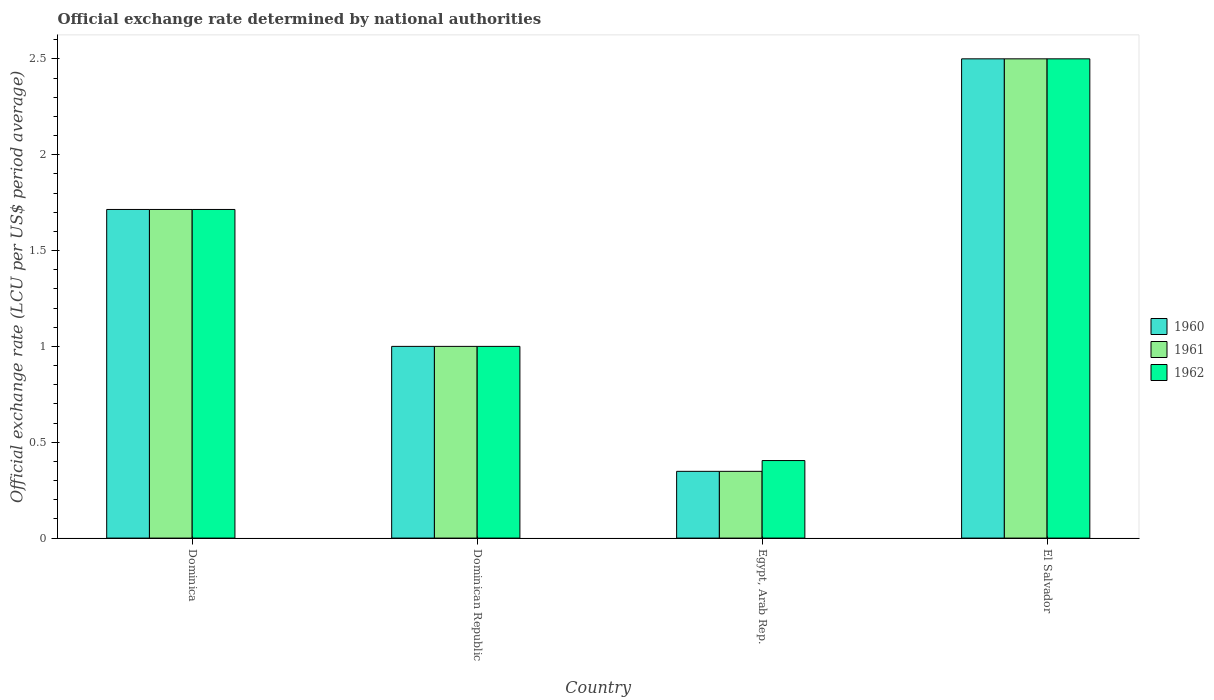Are the number of bars on each tick of the X-axis equal?
Provide a short and direct response. Yes. How many bars are there on the 1st tick from the left?
Offer a very short reply. 3. What is the label of the 2nd group of bars from the left?
Offer a very short reply. Dominican Republic. What is the official exchange rate in 1962 in El Salvador?
Ensure brevity in your answer.  2.5. Across all countries, what is the maximum official exchange rate in 1960?
Offer a terse response. 2.5. Across all countries, what is the minimum official exchange rate in 1960?
Provide a succinct answer. 0.35. In which country was the official exchange rate in 1962 maximum?
Your response must be concise. El Salvador. In which country was the official exchange rate in 1962 minimum?
Offer a very short reply. Egypt, Arab Rep. What is the total official exchange rate in 1961 in the graph?
Offer a terse response. 5.56. What is the difference between the official exchange rate in 1960 in Egypt, Arab Rep. and that in El Salvador?
Give a very brief answer. -2.15. What is the difference between the official exchange rate in 1962 in Dominican Republic and the official exchange rate in 1961 in Egypt, Arab Rep.?
Your response must be concise. 0.65. What is the average official exchange rate in 1962 per country?
Make the answer very short. 1.4. In how many countries, is the official exchange rate in 1962 greater than 0.1 LCU?
Keep it short and to the point. 4. What is the ratio of the official exchange rate in 1962 in Egypt, Arab Rep. to that in El Salvador?
Provide a succinct answer. 0.16. Is the official exchange rate in 1961 in Dominica less than that in Egypt, Arab Rep.?
Your answer should be compact. No. Is the difference between the official exchange rate in 1960 in Dominica and El Salvador greater than the difference between the official exchange rate in 1962 in Dominica and El Salvador?
Your response must be concise. No. What is the difference between the highest and the second highest official exchange rate in 1961?
Your response must be concise. -0.79. What is the difference between the highest and the lowest official exchange rate in 1962?
Your response must be concise. 2.1. What does the 3rd bar from the left in Dominica represents?
Your answer should be compact. 1962. Is it the case that in every country, the sum of the official exchange rate in 1961 and official exchange rate in 1960 is greater than the official exchange rate in 1962?
Offer a very short reply. Yes. Are the values on the major ticks of Y-axis written in scientific E-notation?
Your answer should be very brief. No. Does the graph contain grids?
Give a very brief answer. No. Where does the legend appear in the graph?
Your answer should be compact. Center right. How are the legend labels stacked?
Offer a terse response. Vertical. What is the title of the graph?
Provide a short and direct response. Official exchange rate determined by national authorities. Does "1993" appear as one of the legend labels in the graph?
Offer a terse response. No. What is the label or title of the X-axis?
Make the answer very short. Country. What is the label or title of the Y-axis?
Ensure brevity in your answer.  Official exchange rate (LCU per US$ period average). What is the Official exchange rate (LCU per US$ period average) in 1960 in Dominica?
Your response must be concise. 1.71. What is the Official exchange rate (LCU per US$ period average) of 1961 in Dominica?
Your answer should be very brief. 1.71. What is the Official exchange rate (LCU per US$ period average) in 1962 in Dominica?
Make the answer very short. 1.71. What is the Official exchange rate (LCU per US$ period average) in 1960 in Dominican Republic?
Your answer should be very brief. 1. What is the Official exchange rate (LCU per US$ period average) in 1960 in Egypt, Arab Rep.?
Provide a short and direct response. 0.35. What is the Official exchange rate (LCU per US$ period average) of 1961 in Egypt, Arab Rep.?
Offer a terse response. 0.35. What is the Official exchange rate (LCU per US$ period average) of 1962 in Egypt, Arab Rep.?
Your answer should be very brief. 0.4. What is the Official exchange rate (LCU per US$ period average) in 1960 in El Salvador?
Keep it short and to the point. 2.5. What is the Official exchange rate (LCU per US$ period average) of 1961 in El Salvador?
Provide a short and direct response. 2.5. What is the Official exchange rate (LCU per US$ period average) of 1962 in El Salvador?
Give a very brief answer. 2.5. Across all countries, what is the maximum Official exchange rate (LCU per US$ period average) in 1960?
Provide a succinct answer. 2.5. Across all countries, what is the maximum Official exchange rate (LCU per US$ period average) in 1961?
Your response must be concise. 2.5. Across all countries, what is the maximum Official exchange rate (LCU per US$ period average) of 1962?
Your answer should be very brief. 2.5. Across all countries, what is the minimum Official exchange rate (LCU per US$ period average) of 1960?
Offer a terse response. 0.35. Across all countries, what is the minimum Official exchange rate (LCU per US$ period average) of 1961?
Your answer should be compact. 0.35. Across all countries, what is the minimum Official exchange rate (LCU per US$ period average) in 1962?
Offer a terse response. 0.4. What is the total Official exchange rate (LCU per US$ period average) of 1960 in the graph?
Your answer should be very brief. 5.56. What is the total Official exchange rate (LCU per US$ period average) in 1961 in the graph?
Your response must be concise. 5.56. What is the total Official exchange rate (LCU per US$ period average) of 1962 in the graph?
Ensure brevity in your answer.  5.62. What is the difference between the Official exchange rate (LCU per US$ period average) of 1960 in Dominica and that in Dominican Republic?
Your answer should be compact. 0.71. What is the difference between the Official exchange rate (LCU per US$ period average) in 1961 in Dominica and that in Dominican Republic?
Offer a very short reply. 0.71. What is the difference between the Official exchange rate (LCU per US$ period average) in 1960 in Dominica and that in Egypt, Arab Rep.?
Give a very brief answer. 1.37. What is the difference between the Official exchange rate (LCU per US$ period average) of 1961 in Dominica and that in Egypt, Arab Rep.?
Provide a short and direct response. 1.37. What is the difference between the Official exchange rate (LCU per US$ period average) of 1962 in Dominica and that in Egypt, Arab Rep.?
Provide a succinct answer. 1.31. What is the difference between the Official exchange rate (LCU per US$ period average) in 1960 in Dominica and that in El Salvador?
Offer a very short reply. -0.79. What is the difference between the Official exchange rate (LCU per US$ period average) of 1961 in Dominica and that in El Salvador?
Your response must be concise. -0.79. What is the difference between the Official exchange rate (LCU per US$ period average) of 1962 in Dominica and that in El Salvador?
Keep it short and to the point. -0.79. What is the difference between the Official exchange rate (LCU per US$ period average) in 1960 in Dominican Republic and that in Egypt, Arab Rep.?
Keep it short and to the point. 0.65. What is the difference between the Official exchange rate (LCU per US$ period average) in 1961 in Dominican Republic and that in Egypt, Arab Rep.?
Your answer should be compact. 0.65. What is the difference between the Official exchange rate (LCU per US$ period average) of 1962 in Dominican Republic and that in Egypt, Arab Rep.?
Provide a succinct answer. 0.6. What is the difference between the Official exchange rate (LCU per US$ period average) of 1960 in Dominican Republic and that in El Salvador?
Make the answer very short. -1.5. What is the difference between the Official exchange rate (LCU per US$ period average) of 1962 in Dominican Republic and that in El Salvador?
Your answer should be compact. -1.5. What is the difference between the Official exchange rate (LCU per US$ period average) of 1960 in Egypt, Arab Rep. and that in El Salvador?
Offer a very short reply. -2.15. What is the difference between the Official exchange rate (LCU per US$ period average) in 1961 in Egypt, Arab Rep. and that in El Salvador?
Offer a terse response. -2.15. What is the difference between the Official exchange rate (LCU per US$ period average) of 1962 in Egypt, Arab Rep. and that in El Salvador?
Ensure brevity in your answer.  -2.1. What is the difference between the Official exchange rate (LCU per US$ period average) of 1960 in Dominica and the Official exchange rate (LCU per US$ period average) of 1961 in Dominican Republic?
Keep it short and to the point. 0.71. What is the difference between the Official exchange rate (LCU per US$ period average) in 1961 in Dominica and the Official exchange rate (LCU per US$ period average) in 1962 in Dominican Republic?
Provide a succinct answer. 0.71. What is the difference between the Official exchange rate (LCU per US$ period average) of 1960 in Dominica and the Official exchange rate (LCU per US$ period average) of 1961 in Egypt, Arab Rep.?
Offer a terse response. 1.37. What is the difference between the Official exchange rate (LCU per US$ period average) of 1960 in Dominica and the Official exchange rate (LCU per US$ period average) of 1962 in Egypt, Arab Rep.?
Make the answer very short. 1.31. What is the difference between the Official exchange rate (LCU per US$ period average) of 1961 in Dominica and the Official exchange rate (LCU per US$ period average) of 1962 in Egypt, Arab Rep.?
Offer a terse response. 1.31. What is the difference between the Official exchange rate (LCU per US$ period average) in 1960 in Dominica and the Official exchange rate (LCU per US$ period average) in 1961 in El Salvador?
Your answer should be very brief. -0.79. What is the difference between the Official exchange rate (LCU per US$ period average) of 1960 in Dominica and the Official exchange rate (LCU per US$ period average) of 1962 in El Salvador?
Give a very brief answer. -0.79. What is the difference between the Official exchange rate (LCU per US$ period average) in 1961 in Dominica and the Official exchange rate (LCU per US$ period average) in 1962 in El Salvador?
Offer a very short reply. -0.79. What is the difference between the Official exchange rate (LCU per US$ period average) in 1960 in Dominican Republic and the Official exchange rate (LCU per US$ period average) in 1961 in Egypt, Arab Rep.?
Your answer should be very brief. 0.65. What is the difference between the Official exchange rate (LCU per US$ period average) of 1960 in Dominican Republic and the Official exchange rate (LCU per US$ period average) of 1962 in Egypt, Arab Rep.?
Make the answer very short. 0.6. What is the difference between the Official exchange rate (LCU per US$ period average) of 1961 in Dominican Republic and the Official exchange rate (LCU per US$ period average) of 1962 in Egypt, Arab Rep.?
Make the answer very short. 0.6. What is the difference between the Official exchange rate (LCU per US$ period average) in 1960 in Egypt, Arab Rep. and the Official exchange rate (LCU per US$ period average) in 1961 in El Salvador?
Provide a short and direct response. -2.15. What is the difference between the Official exchange rate (LCU per US$ period average) in 1960 in Egypt, Arab Rep. and the Official exchange rate (LCU per US$ period average) in 1962 in El Salvador?
Offer a terse response. -2.15. What is the difference between the Official exchange rate (LCU per US$ period average) in 1961 in Egypt, Arab Rep. and the Official exchange rate (LCU per US$ period average) in 1962 in El Salvador?
Ensure brevity in your answer.  -2.15. What is the average Official exchange rate (LCU per US$ period average) of 1960 per country?
Keep it short and to the point. 1.39. What is the average Official exchange rate (LCU per US$ period average) in 1961 per country?
Make the answer very short. 1.39. What is the average Official exchange rate (LCU per US$ period average) of 1962 per country?
Give a very brief answer. 1.4. What is the difference between the Official exchange rate (LCU per US$ period average) of 1960 and Official exchange rate (LCU per US$ period average) of 1961 in Dominica?
Ensure brevity in your answer.  0. What is the difference between the Official exchange rate (LCU per US$ period average) of 1960 and Official exchange rate (LCU per US$ period average) of 1962 in Dominican Republic?
Your response must be concise. 0. What is the difference between the Official exchange rate (LCU per US$ period average) in 1961 and Official exchange rate (LCU per US$ period average) in 1962 in Dominican Republic?
Give a very brief answer. 0. What is the difference between the Official exchange rate (LCU per US$ period average) in 1960 and Official exchange rate (LCU per US$ period average) in 1961 in Egypt, Arab Rep.?
Keep it short and to the point. 0. What is the difference between the Official exchange rate (LCU per US$ period average) in 1960 and Official exchange rate (LCU per US$ period average) in 1962 in Egypt, Arab Rep.?
Provide a succinct answer. -0.06. What is the difference between the Official exchange rate (LCU per US$ period average) in 1961 and Official exchange rate (LCU per US$ period average) in 1962 in Egypt, Arab Rep.?
Your answer should be compact. -0.06. What is the difference between the Official exchange rate (LCU per US$ period average) in 1961 and Official exchange rate (LCU per US$ period average) in 1962 in El Salvador?
Your response must be concise. 0. What is the ratio of the Official exchange rate (LCU per US$ period average) of 1960 in Dominica to that in Dominican Republic?
Give a very brief answer. 1.71. What is the ratio of the Official exchange rate (LCU per US$ period average) in 1961 in Dominica to that in Dominican Republic?
Provide a succinct answer. 1.71. What is the ratio of the Official exchange rate (LCU per US$ period average) of 1962 in Dominica to that in Dominican Republic?
Provide a succinct answer. 1.71. What is the ratio of the Official exchange rate (LCU per US$ period average) in 1960 in Dominica to that in Egypt, Arab Rep.?
Offer a very short reply. 4.92. What is the ratio of the Official exchange rate (LCU per US$ period average) of 1961 in Dominica to that in Egypt, Arab Rep.?
Ensure brevity in your answer.  4.92. What is the ratio of the Official exchange rate (LCU per US$ period average) in 1962 in Dominica to that in Egypt, Arab Rep.?
Your response must be concise. 4.24. What is the ratio of the Official exchange rate (LCU per US$ period average) of 1960 in Dominica to that in El Salvador?
Your answer should be very brief. 0.69. What is the ratio of the Official exchange rate (LCU per US$ period average) of 1961 in Dominica to that in El Salvador?
Your answer should be very brief. 0.69. What is the ratio of the Official exchange rate (LCU per US$ period average) in 1962 in Dominica to that in El Salvador?
Your answer should be very brief. 0.69. What is the ratio of the Official exchange rate (LCU per US$ period average) of 1960 in Dominican Republic to that in Egypt, Arab Rep.?
Your answer should be compact. 2.87. What is the ratio of the Official exchange rate (LCU per US$ period average) in 1961 in Dominican Republic to that in Egypt, Arab Rep.?
Make the answer very short. 2.87. What is the ratio of the Official exchange rate (LCU per US$ period average) of 1962 in Dominican Republic to that in Egypt, Arab Rep.?
Offer a very short reply. 2.47. What is the ratio of the Official exchange rate (LCU per US$ period average) in 1960 in Dominican Republic to that in El Salvador?
Offer a terse response. 0.4. What is the ratio of the Official exchange rate (LCU per US$ period average) in 1960 in Egypt, Arab Rep. to that in El Salvador?
Offer a terse response. 0.14. What is the ratio of the Official exchange rate (LCU per US$ period average) of 1961 in Egypt, Arab Rep. to that in El Salvador?
Keep it short and to the point. 0.14. What is the ratio of the Official exchange rate (LCU per US$ period average) in 1962 in Egypt, Arab Rep. to that in El Salvador?
Your answer should be very brief. 0.16. What is the difference between the highest and the second highest Official exchange rate (LCU per US$ period average) of 1960?
Make the answer very short. 0.79. What is the difference between the highest and the second highest Official exchange rate (LCU per US$ period average) of 1961?
Provide a short and direct response. 0.79. What is the difference between the highest and the second highest Official exchange rate (LCU per US$ period average) in 1962?
Your answer should be compact. 0.79. What is the difference between the highest and the lowest Official exchange rate (LCU per US$ period average) of 1960?
Your response must be concise. 2.15. What is the difference between the highest and the lowest Official exchange rate (LCU per US$ period average) in 1961?
Keep it short and to the point. 2.15. What is the difference between the highest and the lowest Official exchange rate (LCU per US$ period average) of 1962?
Keep it short and to the point. 2.1. 